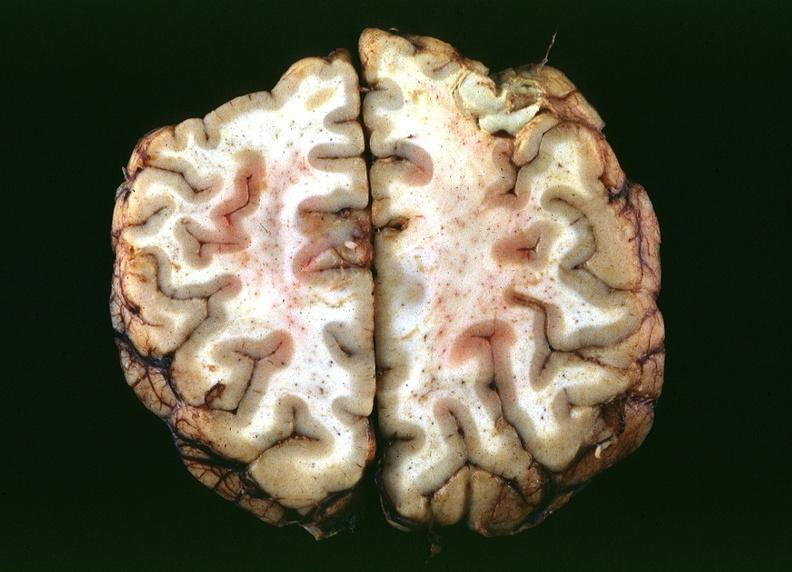what is present?
Answer the question using a single word or phrase. Nervous 